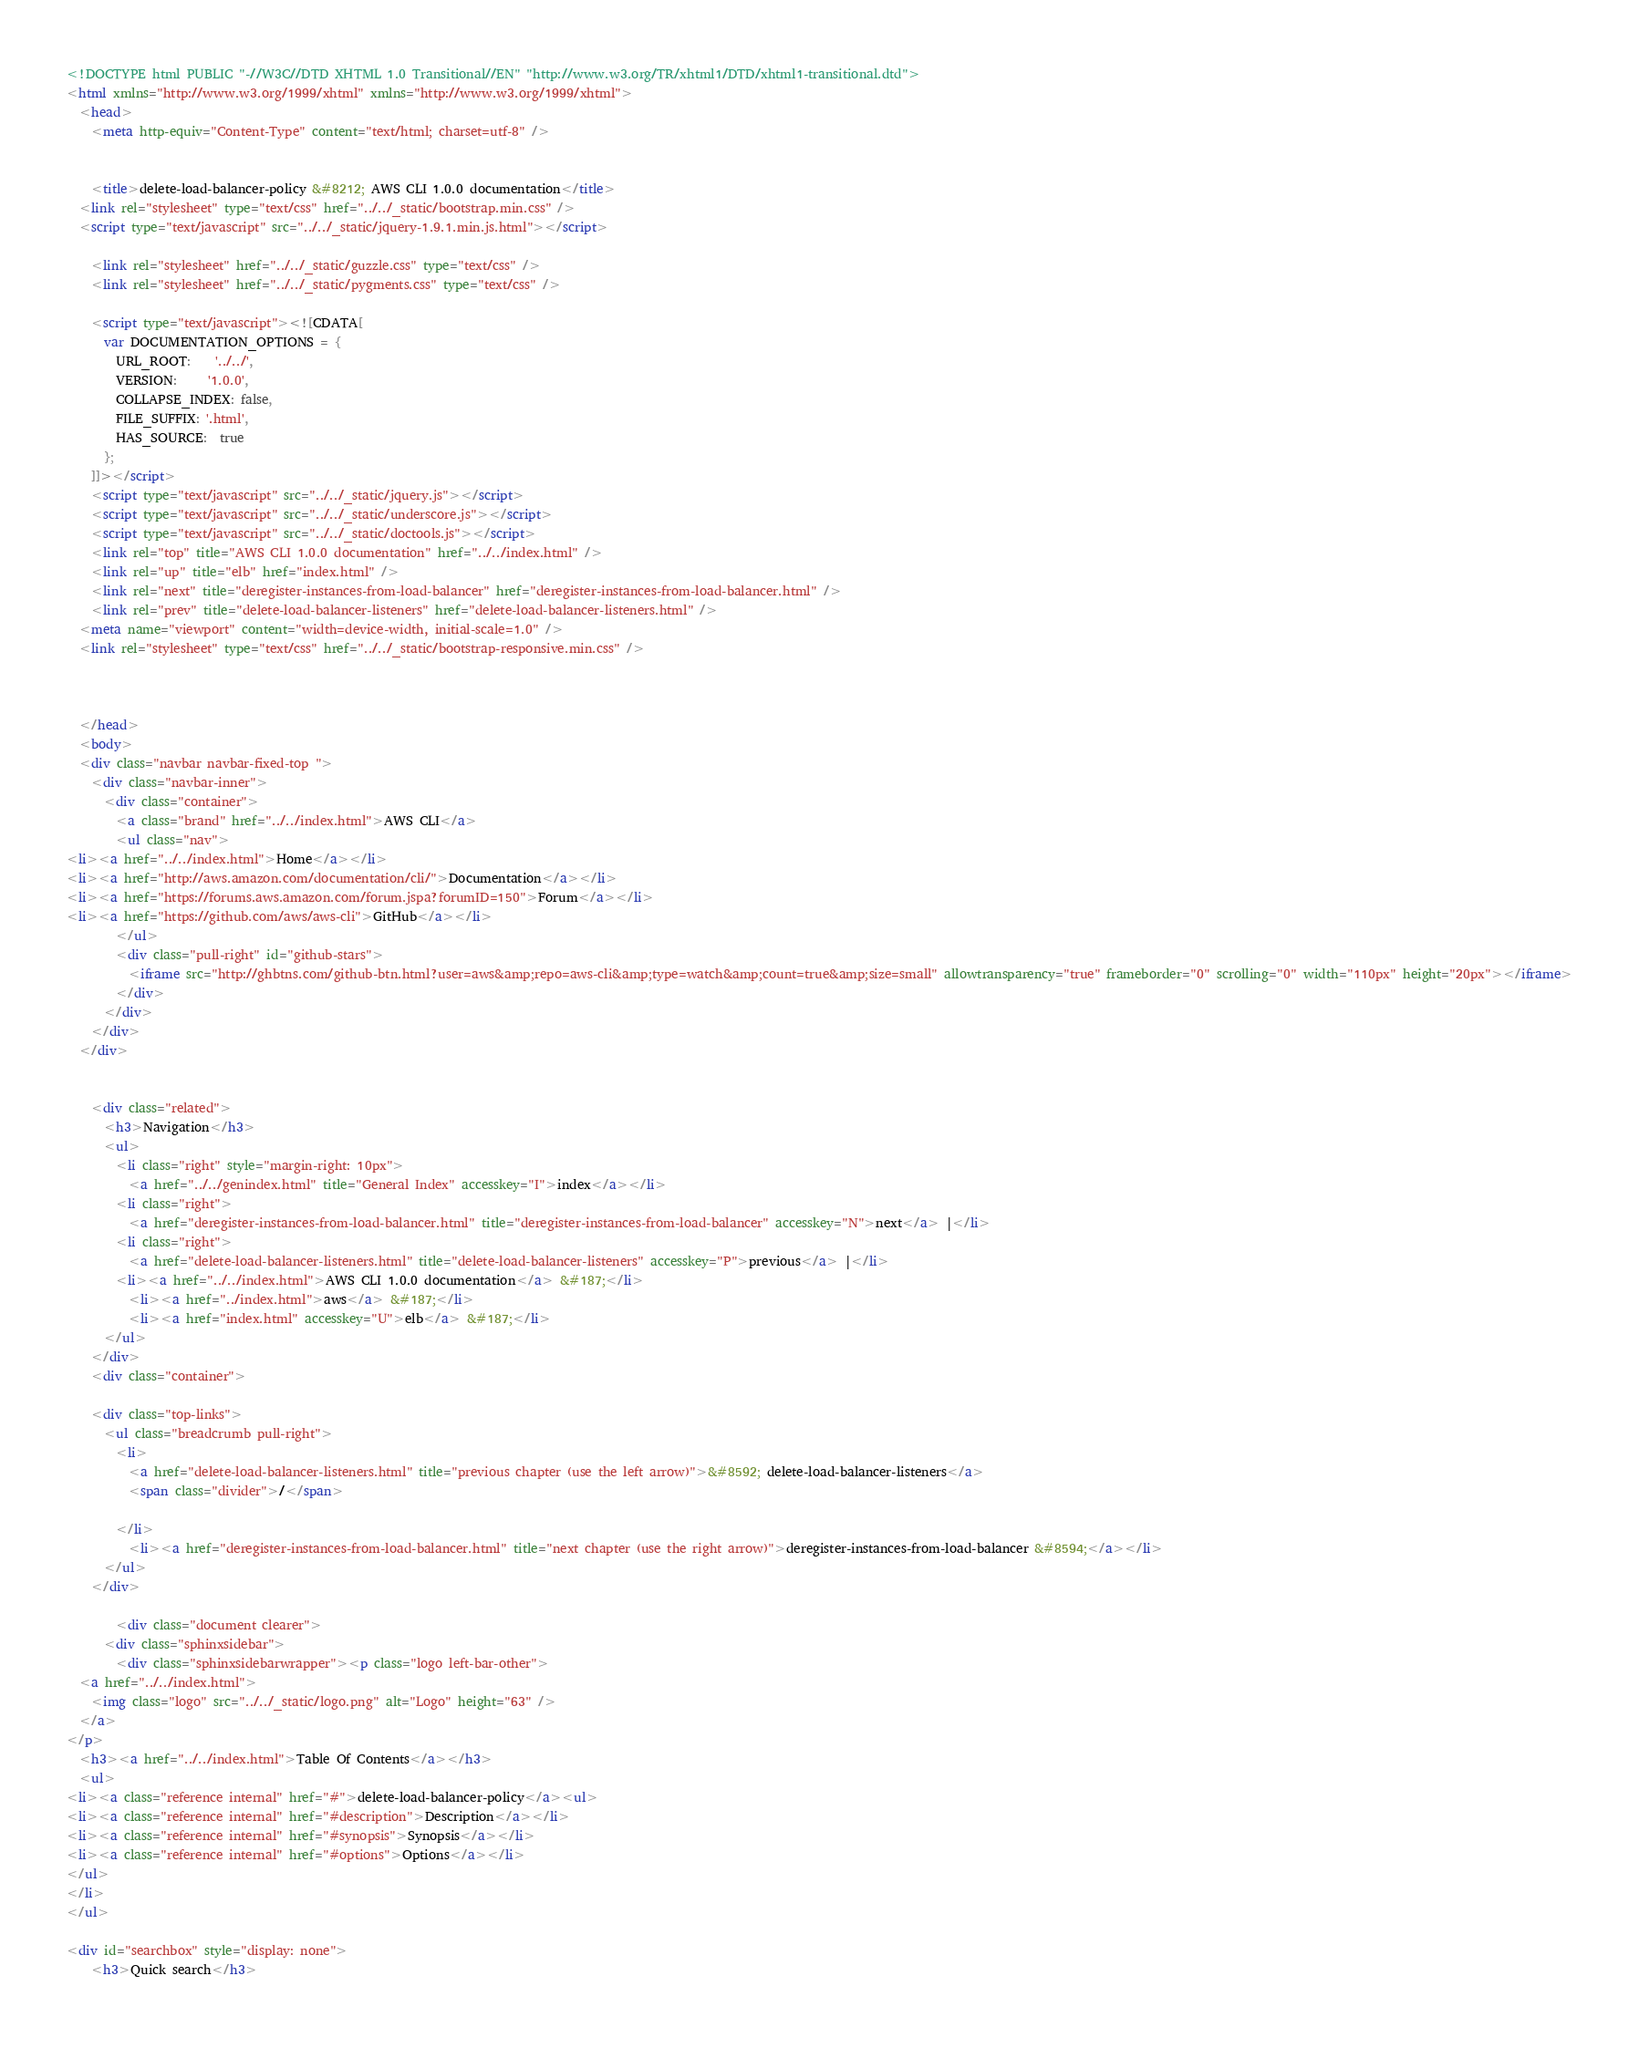<code> <loc_0><loc_0><loc_500><loc_500><_HTML_><!DOCTYPE html PUBLIC "-//W3C//DTD XHTML 1.0 Transitional//EN" "http://www.w3.org/TR/xhtml1/DTD/xhtml1-transitional.dtd">
<html xmlns="http://www.w3.org/1999/xhtml" xmlns="http://www.w3.org/1999/xhtml">
  <head>
    <meta http-equiv="Content-Type" content="text/html; charset=utf-8" />
    
  
    <title>delete-load-balancer-policy &#8212; AWS CLI 1.0.0 documentation</title>
  <link rel="stylesheet" type="text/css" href="../../_static/bootstrap.min.css" />
  <script type="text/javascript" src="../../_static/jquery-1.9.1.min.js.html"></script>
    
    <link rel="stylesheet" href="../../_static/guzzle.css" type="text/css" />
    <link rel="stylesheet" href="../../_static/pygments.css" type="text/css" />
    
    <script type="text/javascript"><![CDATA[
      var DOCUMENTATION_OPTIONS = {
        URL_ROOT:    '../../',
        VERSION:     '1.0.0',
        COLLAPSE_INDEX: false,
        FILE_SUFFIX: '.html',
        HAS_SOURCE:  true
      };
    ]]></script>
    <script type="text/javascript" src="../../_static/jquery.js"></script>
    <script type="text/javascript" src="../../_static/underscore.js"></script>
    <script type="text/javascript" src="../../_static/doctools.js"></script>
    <link rel="top" title="AWS CLI 1.0.0 documentation" href="../../index.html" />
    <link rel="up" title="elb" href="index.html" />
    <link rel="next" title="deregister-instances-from-load-balancer" href="deregister-instances-from-load-balancer.html" />
    <link rel="prev" title="delete-load-balancer-listeners" href="delete-load-balancer-listeners.html" />
  <meta name="viewport" content="width=device-width, initial-scale=1.0" />
  <link rel="stylesheet" type="text/css" href="../../_static/bootstrap-responsive.min.css" />
  
   

  </head>
  <body>
  <div class="navbar navbar-fixed-top ">
    <div class="navbar-inner">
      <div class="container">
        <a class="brand" href="../../index.html">AWS CLI</a>
        <ul class="nav">
<li><a href="../../index.html">Home</a></li>
<li><a href="http://aws.amazon.com/documentation/cli/">Documentation</a></li>
<li><a href="https://forums.aws.amazon.com/forum.jspa?forumID=150">Forum</a></li>
<li><a href="https://github.com/aws/aws-cli">GitHub</a></li>
        </ul>
        <div class="pull-right" id="github-stars">
          <iframe src="http://ghbtns.com/github-btn.html?user=aws&amp;repo=aws-cli&amp;type=watch&amp;count=true&amp;size=small" allowtransparency="true" frameborder="0" scrolling="0" width="110px" height="20px"></iframe>
        </div>
      </div>
    </div>
  </div>
  

    <div class="related">
      <h3>Navigation</h3>
      <ul>
        <li class="right" style="margin-right: 10px">
          <a href="../../genindex.html" title="General Index" accesskey="I">index</a></li>
        <li class="right">
          <a href="deregister-instances-from-load-balancer.html" title="deregister-instances-from-load-balancer" accesskey="N">next</a> |</li>
        <li class="right">
          <a href="delete-load-balancer-listeners.html" title="delete-load-balancer-listeners" accesskey="P">previous</a> |</li>
        <li><a href="../../index.html">AWS CLI 1.0.0 documentation</a> &#187;</li>
          <li><a href="../index.html">aws</a> &#187;</li>
          <li><a href="index.html" accesskey="U">elb</a> &#187;</li> 
      </ul>
    </div>
    <div class="container">
        
    <div class="top-links">
      <ul class="breadcrumb pull-right">
        <li>
          <a href="delete-load-balancer-listeners.html" title="previous chapter (use the left arrow)">&#8592; delete-load-balancer-listeners</a>
          <span class="divider">/</span>
          
        </li>
          <li><a href="deregister-instances-from-load-balancer.html" title="next chapter (use the right arrow)">deregister-instances-from-load-balancer &#8594;</a></li>
      </ul>
    </div>
  
        <div class="document clearer">
      <div class="sphinxsidebar">
        <div class="sphinxsidebarwrapper"><p class="logo left-bar-other">
  <a href="../../index.html">
    <img class="logo" src="../../_static/logo.png" alt="Logo" height="63" />
  </a>
</p>
  <h3><a href="../../index.html">Table Of Contents</a></h3>
  <ul>
<li><a class="reference internal" href="#">delete-load-balancer-policy</a><ul>
<li><a class="reference internal" href="#description">Description</a></li>
<li><a class="reference internal" href="#synopsis">Synopsis</a></li>
<li><a class="reference internal" href="#options">Options</a></li>
</ul>
</li>
</ul>

<div id="searchbox" style="display: none">
    <h3>Quick search</h3></code> 